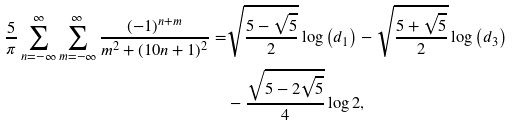<formula> <loc_0><loc_0><loc_500><loc_500>\frac { 5 } { \pi } \sum _ { n = - \infty } ^ { \infty } \sum _ { m = - \infty } ^ { \infty } \frac { ( - 1 ) ^ { n + m } } { m ^ { 2 } + ( 1 0 n + 1 ) ^ { 2 } } = & \sqrt { \frac { 5 - \sqrt { 5 } } { 2 } } \log \left ( d _ { 1 } \right ) - \sqrt { \frac { 5 + \sqrt { 5 } } { 2 } } \log \left ( d _ { 3 } \right ) \\ & - \frac { \sqrt { 5 - 2 \sqrt { 5 } } } { 4 } \log 2 ,</formula> 